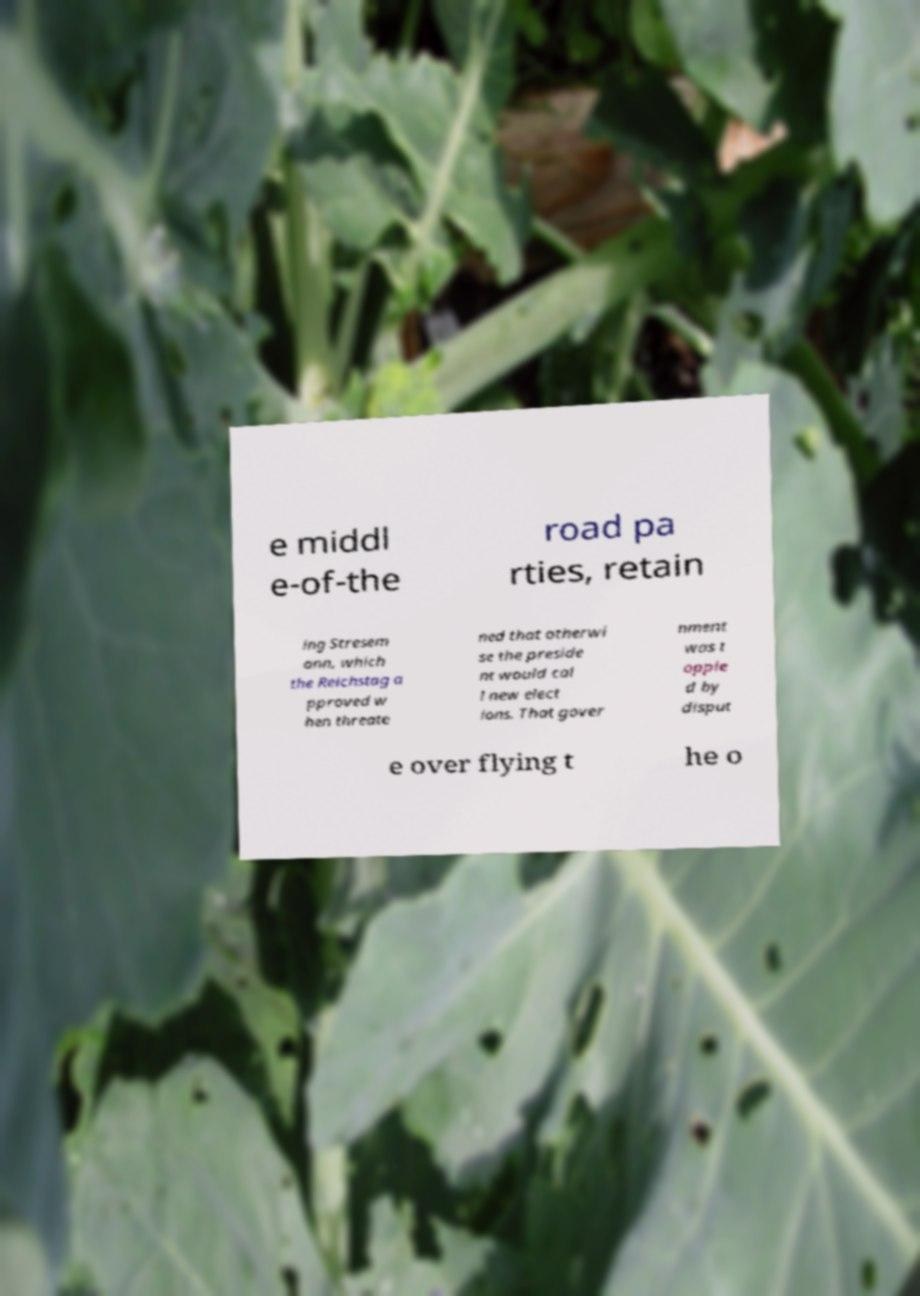Can you accurately transcribe the text from the provided image for me? e middl e-of-the road pa rties, retain ing Stresem ann, which the Reichstag a pproved w hen threate ned that otherwi se the preside nt would cal l new elect ions. That gover nment was t opple d by disput e over flying t he o 